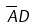Convert formula to latex. <formula><loc_0><loc_0><loc_500><loc_500>\overline { A } D</formula> 